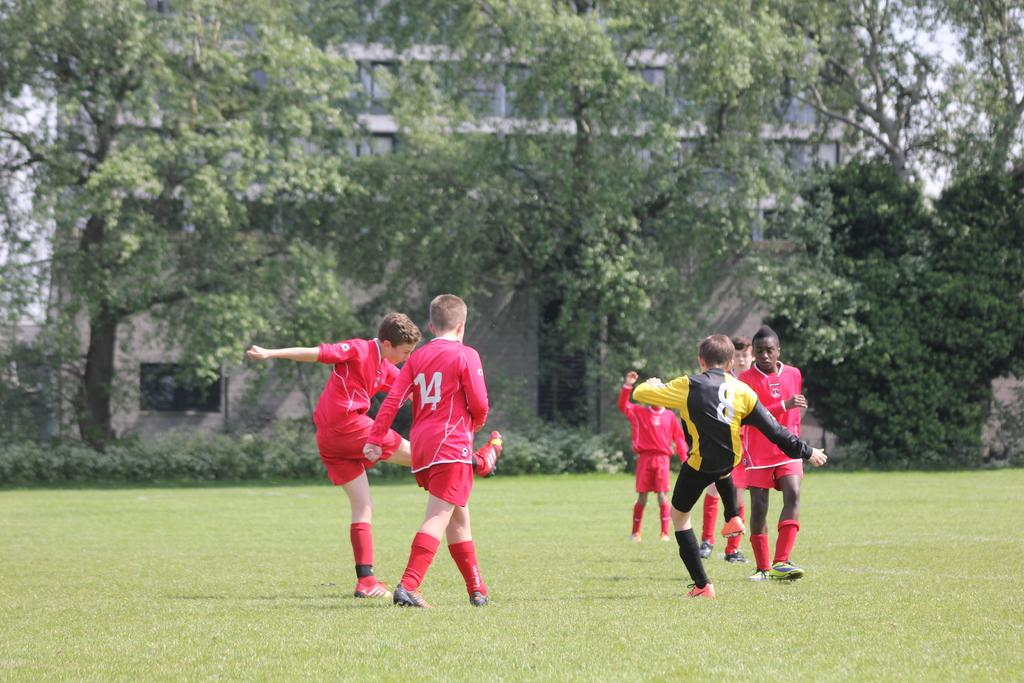How many boys are present in the image? There are five boys in the image. What are the boys wearing? The boys are wearing red t-shirts and shorts. What activity are the boys engaged in? The boys are playing football. Where is the football game taking place? The football game is taking place on a grass ground. What can be seen in the background of the image? There are trees and at least one building visible in the background. What type of clouds can be seen in the image? There are no clouds visible in the image; it features a football game on a grass ground with trees and a building in the background. 